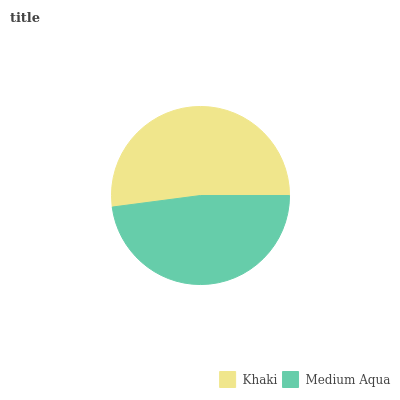Is Medium Aqua the minimum?
Answer yes or no. Yes. Is Khaki the maximum?
Answer yes or no. Yes. Is Medium Aqua the maximum?
Answer yes or no. No. Is Khaki greater than Medium Aqua?
Answer yes or no. Yes. Is Medium Aqua less than Khaki?
Answer yes or no. Yes. Is Medium Aqua greater than Khaki?
Answer yes or no. No. Is Khaki less than Medium Aqua?
Answer yes or no. No. Is Khaki the high median?
Answer yes or no. Yes. Is Medium Aqua the low median?
Answer yes or no. Yes. Is Medium Aqua the high median?
Answer yes or no. No. Is Khaki the low median?
Answer yes or no. No. 